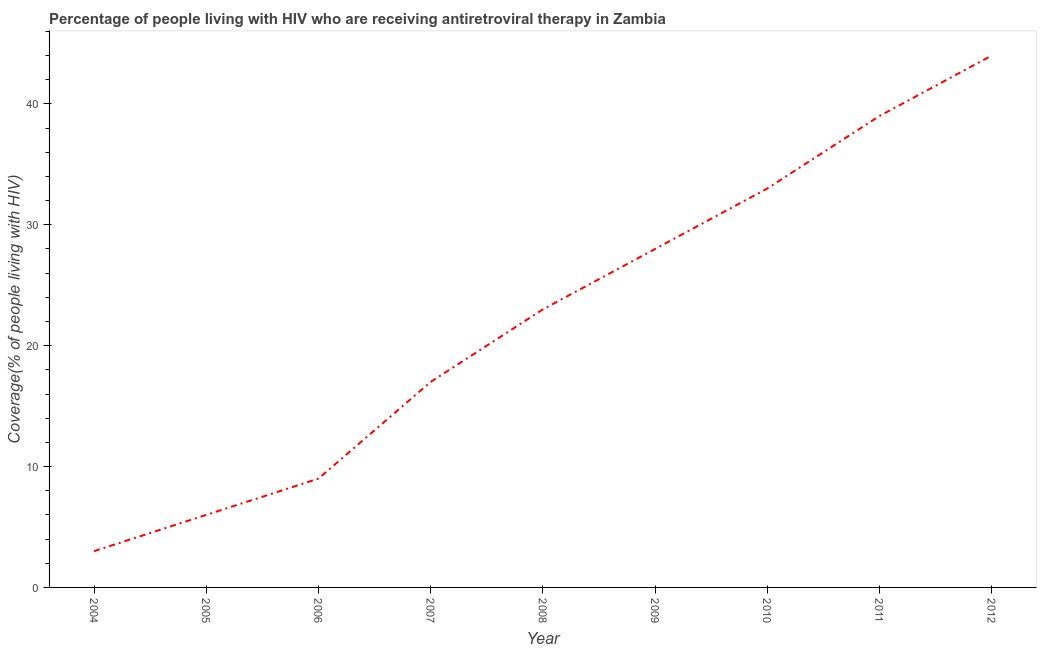What is the antiretroviral therapy coverage in 2009?
Your answer should be compact. 28. Across all years, what is the maximum antiretroviral therapy coverage?
Your answer should be compact. 44. Across all years, what is the minimum antiretroviral therapy coverage?
Provide a succinct answer. 3. In which year was the antiretroviral therapy coverage maximum?
Ensure brevity in your answer.  2012. What is the sum of the antiretroviral therapy coverage?
Make the answer very short. 202. What is the difference between the antiretroviral therapy coverage in 2005 and 2010?
Offer a very short reply. -27. What is the average antiretroviral therapy coverage per year?
Provide a succinct answer. 22.44. What is the median antiretroviral therapy coverage?
Your answer should be compact. 23. In how many years, is the antiretroviral therapy coverage greater than 38 %?
Offer a very short reply. 2. Do a majority of the years between 2012 and 2008 (inclusive) have antiretroviral therapy coverage greater than 36 %?
Give a very brief answer. Yes. What is the ratio of the antiretroviral therapy coverage in 2007 to that in 2010?
Your response must be concise. 0.52. Is the antiretroviral therapy coverage in 2007 less than that in 2008?
Your response must be concise. Yes. What is the difference between the highest and the lowest antiretroviral therapy coverage?
Make the answer very short. 41. In how many years, is the antiretroviral therapy coverage greater than the average antiretroviral therapy coverage taken over all years?
Keep it short and to the point. 5. Does the antiretroviral therapy coverage monotonically increase over the years?
Offer a terse response. Yes. How many years are there in the graph?
Give a very brief answer. 9. What is the difference between two consecutive major ticks on the Y-axis?
Offer a terse response. 10. Does the graph contain any zero values?
Keep it short and to the point. No. What is the title of the graph?
Provide a short and direct response. Percentage of people living with HIV who are receiving antiretroviral therapy in Zambia. What is the label or title of the Y-axis?
Make the answer very short. Coverage(% of people living with HIV). What is the Coverage(% of people living with HIV) of 2004?
Ensure brevity in your answer.  3. What is the Coverage(% of people living with HIV) of 2005?
Your answer should be very brief. 6. What is the Coverage(% of people living with HIV) in 2006?
Offer a very short reply. 9. What is the Coverage(% of people living with HIV) in 2007?
Offer a very short reply. 17. What is the Coverage(% of people living with HIV) in 2009?
Your response must be concise. 28. What is the Coverage(% of people living with HIV) in 2010?
Give a very brief answer. 33. What is the Coverage(% of people living with HIV) in 2011?
Give a very brief answer. 39. What is the Coverage(% of people living with HIV) in 2012?
Provide a succinct answer. 44. What is the difference between the Coverage(% of people living with HIV) in 2004 and 2006?
Offer a terse response. -6. What is the difference between the Coverage(% of people living with HIV) in 2004 and 2007?
Your answer should be very brief. -14. What is the difference between the Coverage(% of people living with HIV) in 2004 and 2009?
Make the answer very short. -25. What is the difference between the Coverage(% of people living with HIV) in 2004 and 2010?
Offer a very short reply. -30. What is the difference between the Coverage(% of people living with HIV) in 2004 and 2011?
Offer a very short reply. -36. What is the difference between the Coverage(% of people living with HIV) in 2004 and 2012?
Offer a very short reply. -41. What is the difference between the Coverage(% of people living with HIV) in 2005 and 2006?
Your response must be concise. -3. What is the difference between the Coverage(% of people living with HIV) in 2005 and 2010?
Your answer should be very brief. -27. What is the difference between the Coverage(% of people living with HIV) in 2005 and 2011?
Provide a succinct answer. -33. What is the difference between the Coverage(% of people living with HIV) in 2005 and 2012?
Offer a very short reply. -38. What is the difference between the Coverage(% of people living with HIV) in 2006 and 2007?
Your answer should be very brief. -8. What is the difference between the Coverage(% of people living with HIV) in 2006 and 2012?
Make the answer very short. -35. What is the difference between the Coverage(% of people living with HIV) in 2007 and 2009?
Your response must be concise. -11. What is the difference between the Coverage(% of people living with HIV) in 2007 and 2010?
Ensure brevity in your answer.  -16. What is the difference between the Coverage(% of people living with HIV) in 2008 and 2011?
Provide a short and direct response. -16. What is the difference between the Coverage(% of people living with HIV) in 2008 and 2012?
Make the answer very short. -21. What is the difference between the Coverage(% of people living with HIV) in 2009 and 2011?
Provide a short and direct response. -11. What is the ratio of the Coverage(% of people living with HIV) in 2004 to that in 2006?
Your answer should be very brief. 0.33. What is the ratio of the Coverage(% of people living with HIV) in 2004 to that in 2007?
Make the answer very short. 0.18. What is the ratio of the Coverage(% of people living with HIV) in 2004 to that in 2008?
Give a very brief answer. 0.13. What is the ratio of the Coverage(% of people living with HIV) in 2004 to that in 2009?
Make the answer very short. 0.11. What is the ratio of the Coverage(% of people living with HIV) in 2004 to that in 2010?
Make the answer very short. 0.09. What is the ratio of the Coverage(% of people living with HIV) in 2004 to that in 2011?
Provide a succinct answer. 0.08. What is the ratio of the Coverage(% of people living with HIV) in 2004 to that in 2012?
Offer a very short reply. 0.07. What is the ratio of the Coverage(% of people living with HIV) in 2005 to that in 2006?
Your response must be concise. 0.67. What is the ratio of the Coverage(% of people living with HIV) in 2005 to that in 2007?
Your answer should be compact. 0.35. What is the ratio of the Coverage(% of people living with HIV) in 2005 to that in 2008?
Provide a short and direct response. 0.26. What is the ratio of the Coverage(% of people living with HIV) in 2005 to that in 2009?
Your answer should be compact. 0.21. What is the ratio of the Coverage(% of people living with HIV) in 2005 to that in 2010?
Your answer should be compact. 0.18. What is the ratio of the Coverage(% of people living with HIV) in 2005 to that in 2011?
Offer a very short reply. 0.15. What is the ratio of the Coverage(% of people living with HIV) in 2005 to that in 2012?
Your response must be concise. 0.14. What is the ratio of the Coverage(% of people living with HIV) in 2006 to that in 2007?
Give a very brief answer. 0.53. What is the ratio of the Coverage(% of people living with HIV) in 2006 to that in 2008?
Ensure brevity in your answer.  0.39. What is the ratio of the Coverage(% of people living with HIV) in 2006 to that in 2009?
Provide a succinct answer. 0.32. What is the ratio of the Coverage(% of people living with HIV) in 2006 to that in 2010?
Your answer should be compact. 0.27. What is the ratio of the Coverage(% of people living with HIV) in 2006 to that in 2011?
Make the answer very short. 0.23. What is the ratio of the Coverage(% of people living with HIV) in 2006 to that in 2012?
Provide a short and direct response. 0.2. What is the ratio of the Coverage(% of people living with HIV) in 2007 to that in 2008?
Ensure brevity in your answer.  0.74. What is the ratio of the Coverage(% of people living with HIV) in 2007 to that in 2009?
Provide a short and direct response. 0.61. What is the ratio of the Coverage(% of people living with HIV) in 2007 to that in 2010?
Keep it short and to the point. 0.52. What is the ratio of the Coverage(% of people living with HIV) in 2007 to that in 2011?
Keep it short and to the point. 0.44. What is the ratio of the Coverage(% of people living with HIV) in 2007 to that in 2012?
Your response must be concise. 0.39. What is the ratio of the Coverage(% of people living with HIV) in 2008 to that in 2009?
Your response must be concise. 0.82. What is the ratio of the Coverage(% of people living with HIV) in 2008 to that in 2010?
Offer a very short reply. 0.7. What is the ratio of the Coverage(% of people living with HIV) in 2008 to that in 2011?
Your answer should be very brief. 0.59. What is the ratio of the Coverage(% of people living with HIV) in 2008 to that in 2012?
Your response must be concise. 0.52. What is the ratio of the Coverage(% of people living with HIV) in 2009 to that in 2010?
Your response must be concise. 0.85. What is the ratio of the Coverage(% of people living with HIV) in 2009 to that in 2011?
Your answer should be very brief. 0.72. What is the ratio of the Coverage(% of people living with HIV) in 2009 to that in 2012?
Provide a succinct answer. 0.64. What is the ratio of the Coverage(% of people living with HIV) in 2010 to that in 2011?
Your answer should be very brief. 0.85. What is the ratio of the Coverage(% of people living with HIV) in 2011 to that in 2012?
Offer a terse response. 0.89. 